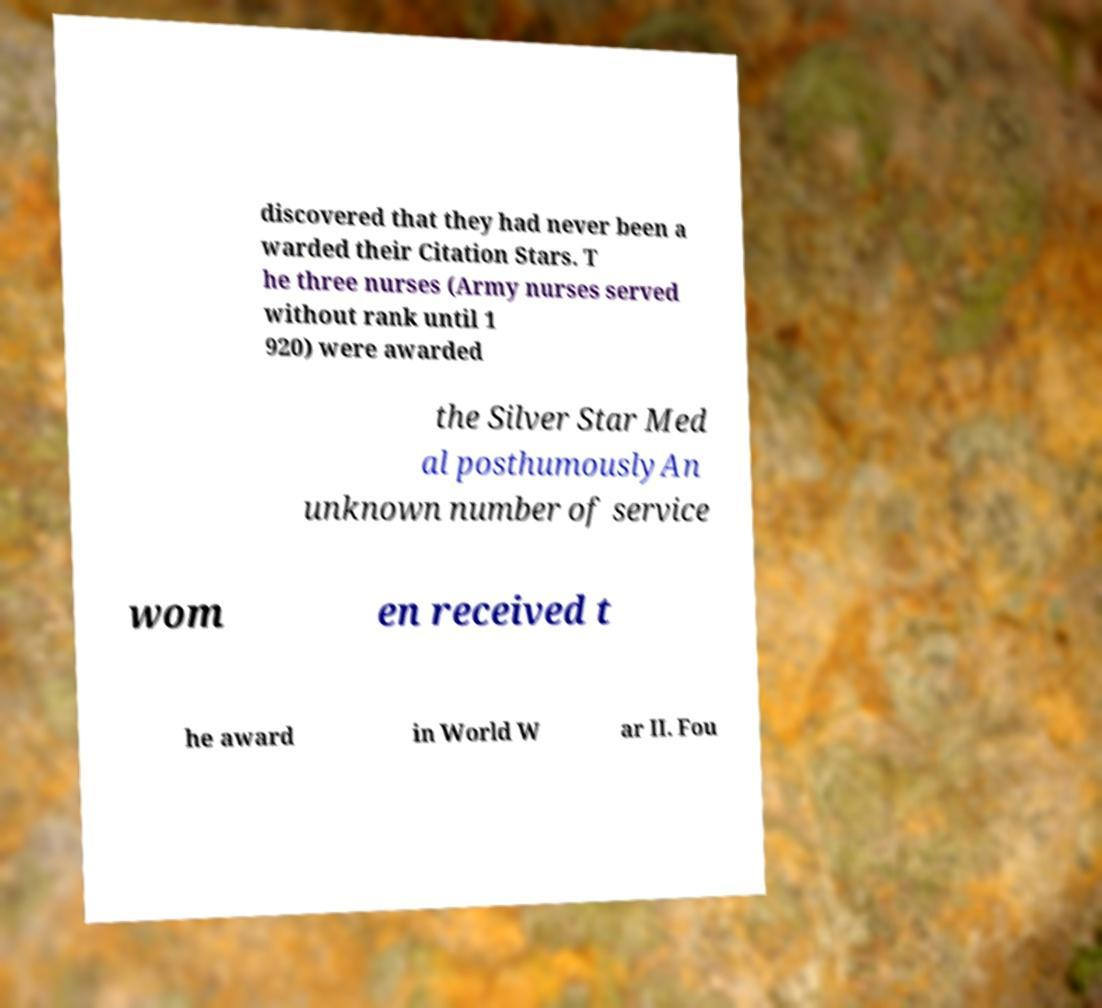There's text embedded in this image that I need extracted. Can you transcribe it verbatim? discovered that they had never been a warded their Citation Stars. T he three nurses (Army nurses served without rank until 1 920) were awarded the Silver Star Med al posthumouslyAn unknown number of service wom en received t he award in World W ar II. Fou 